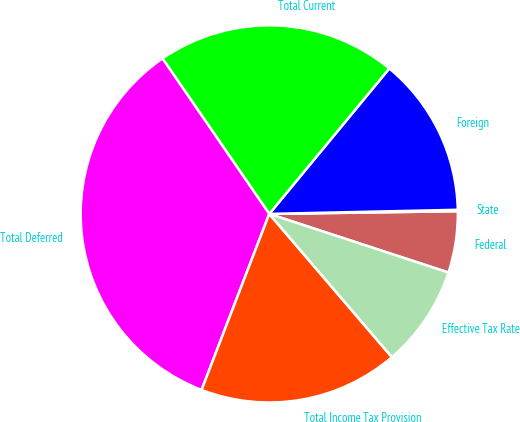<chart> <loc_0><loc_0><loc_500><loc_500><pie_chart><fcel>Federal<fcel>State<fcel>Foreign<fcel>Total Current<fcel>Total Deferred<fcel>Total Income Tax Provision<fcel>Effective Tax Rate<nl><fcel>5.26%<fcel>0.12%<fcel>13.67%<fcel>20.56%<fcel>34.58%<fcel>17.11%<fcel>8.7%<nl></chart> 